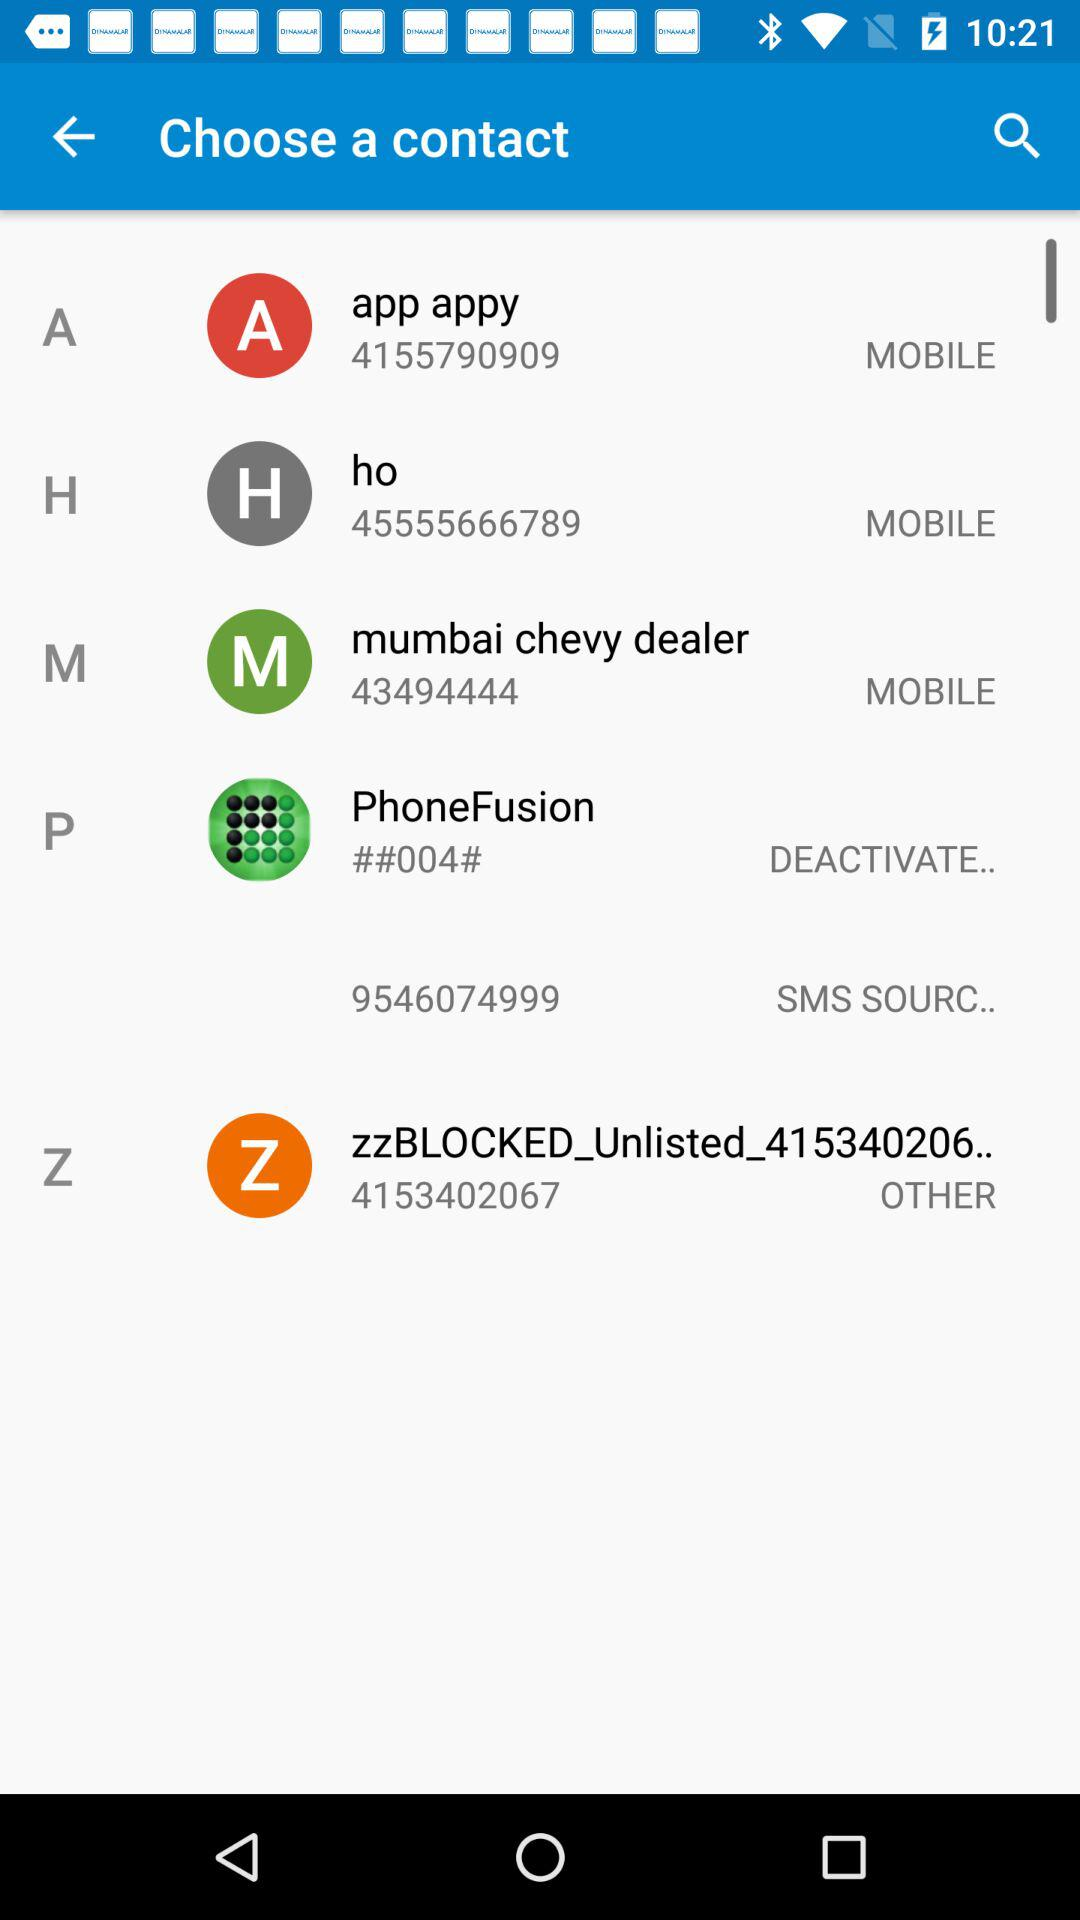What is the contact number of "app appy"? The contact number of "app appy" is 4155790909. 